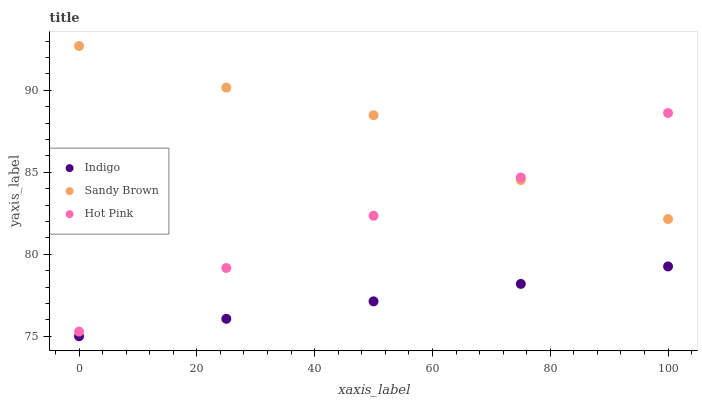Does Indigo have the minimum area under the curve?
Answer yes or no. Yes. Does Sandy Brown have the maximum area under the curve?
Answer yes or no. Yes. Does Hot Pink have the minimum area under the curve?
Answer yes or no. No. Does Hot Pink have the maximum area under the curve?
Answer yes or no. No. Is Indigo the smoothest?
Answer yes or no. Yes. Is Sandy Brown the roughest?
Answer yes or no. Yes. Is Hot Pink the smoothest?
Answer yes or no. No. Is Hot Pink the roughest?
Answer yes or no. No. Does Indigo have the lowest value?
Answer yes or no. Yes. Does Hot Pink have the lowest value?
Answer yes or no. No. Does Sandy Brown have the highest value?
Answer yes or no. Yes. Does Hot Pink have the highest value?
Answer yes or no. No. Is Indigo less than Sandy Brown?
Answer yes or no. Yes. Is Sandy Brown greater than Indigo?
Answer yes or no. Yes. Does Hot Pink intersect Sandy Brown?
Answer yes or no. Yes. Is Hot Pink less than Sandy Brown?
Answer yes or no. No. Is Hot Pink greater than Sandy Brown?
Answer yes or no. No. Does Indigo intersect Sandy Brown?
Answer yes or no. No. 